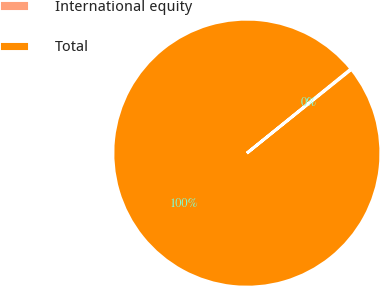Convert chart. <chart><loc_0><loc_0><loc_500><loc_500><pie_chart><fcel>International equity<fcel>Total<nl><fcel>0.09%<fcel>99.91%<nl></chart> 